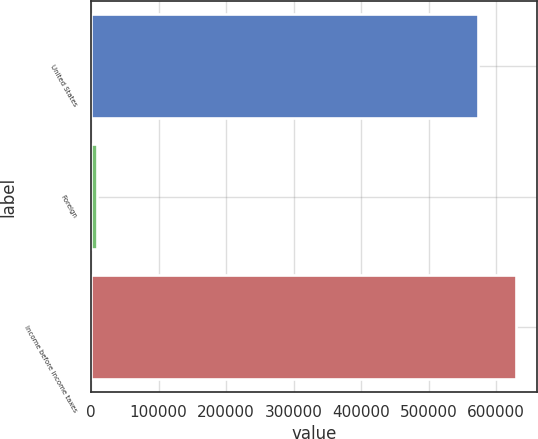Convert chart. <chart><loc_0><loc_0><loc_500><loc_500><bar_chart><fcel>United States<fcel>Foreign<fcel>Income before income taxes<nl><fcel>572226<fcel>8565<fcel>629449<nl></chart> 